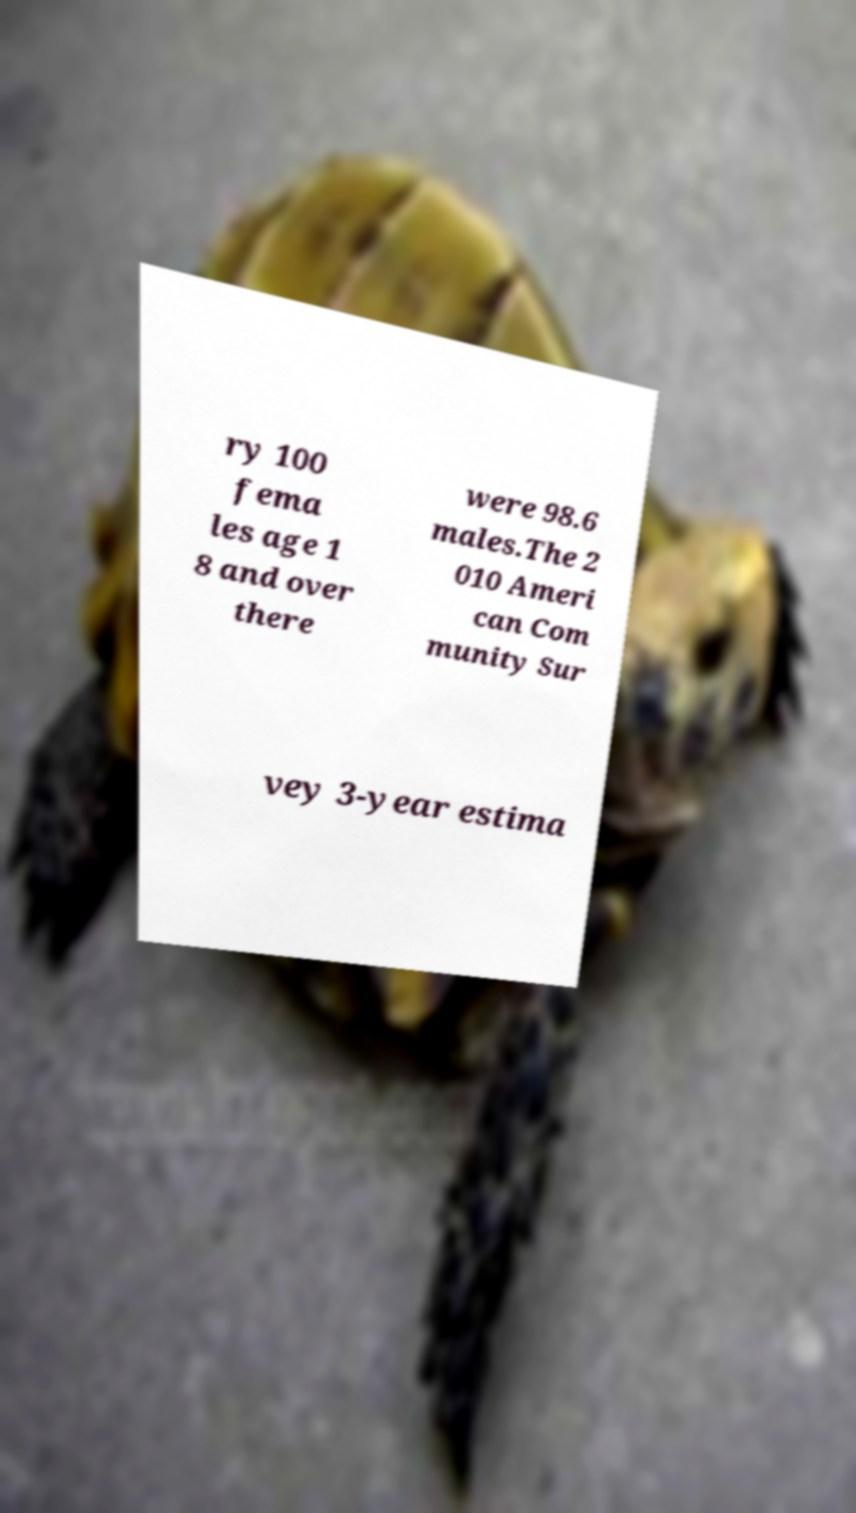Could you assist in decoding the text presented in this image and type it out clearly? ry 100 fema les age 1 8 and over there were 98.6 males.The 2 010 Ameri can Com munity Sur vey 3-year estima 